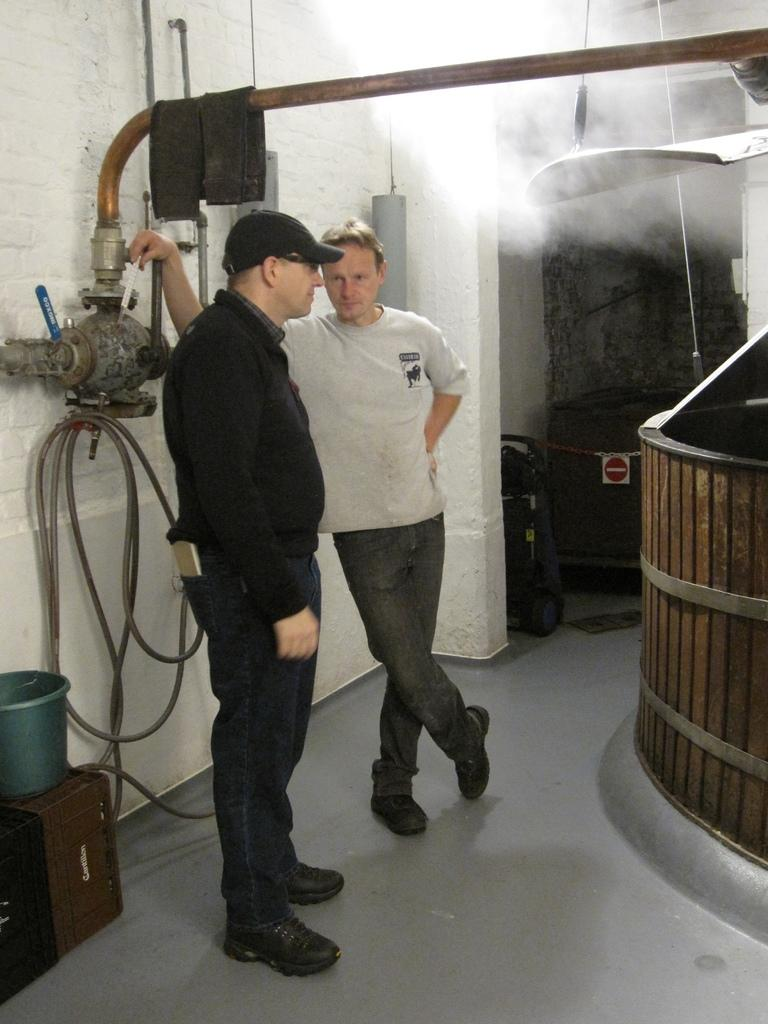How many people are present in the image? There are two persons standing in the image. Can you describe one of the persons in the image? One of the persons is a man. What is the man wearing in the image? The man is wearing a black dress. What can be seen in the background of the image? There is a wall in the background of the image. What type of crime is being committed in the image? There is no indication of any crime being committed in the image. The image simply shows two people, one of whom is a man wearing a black dress, standing in front of a wall. 